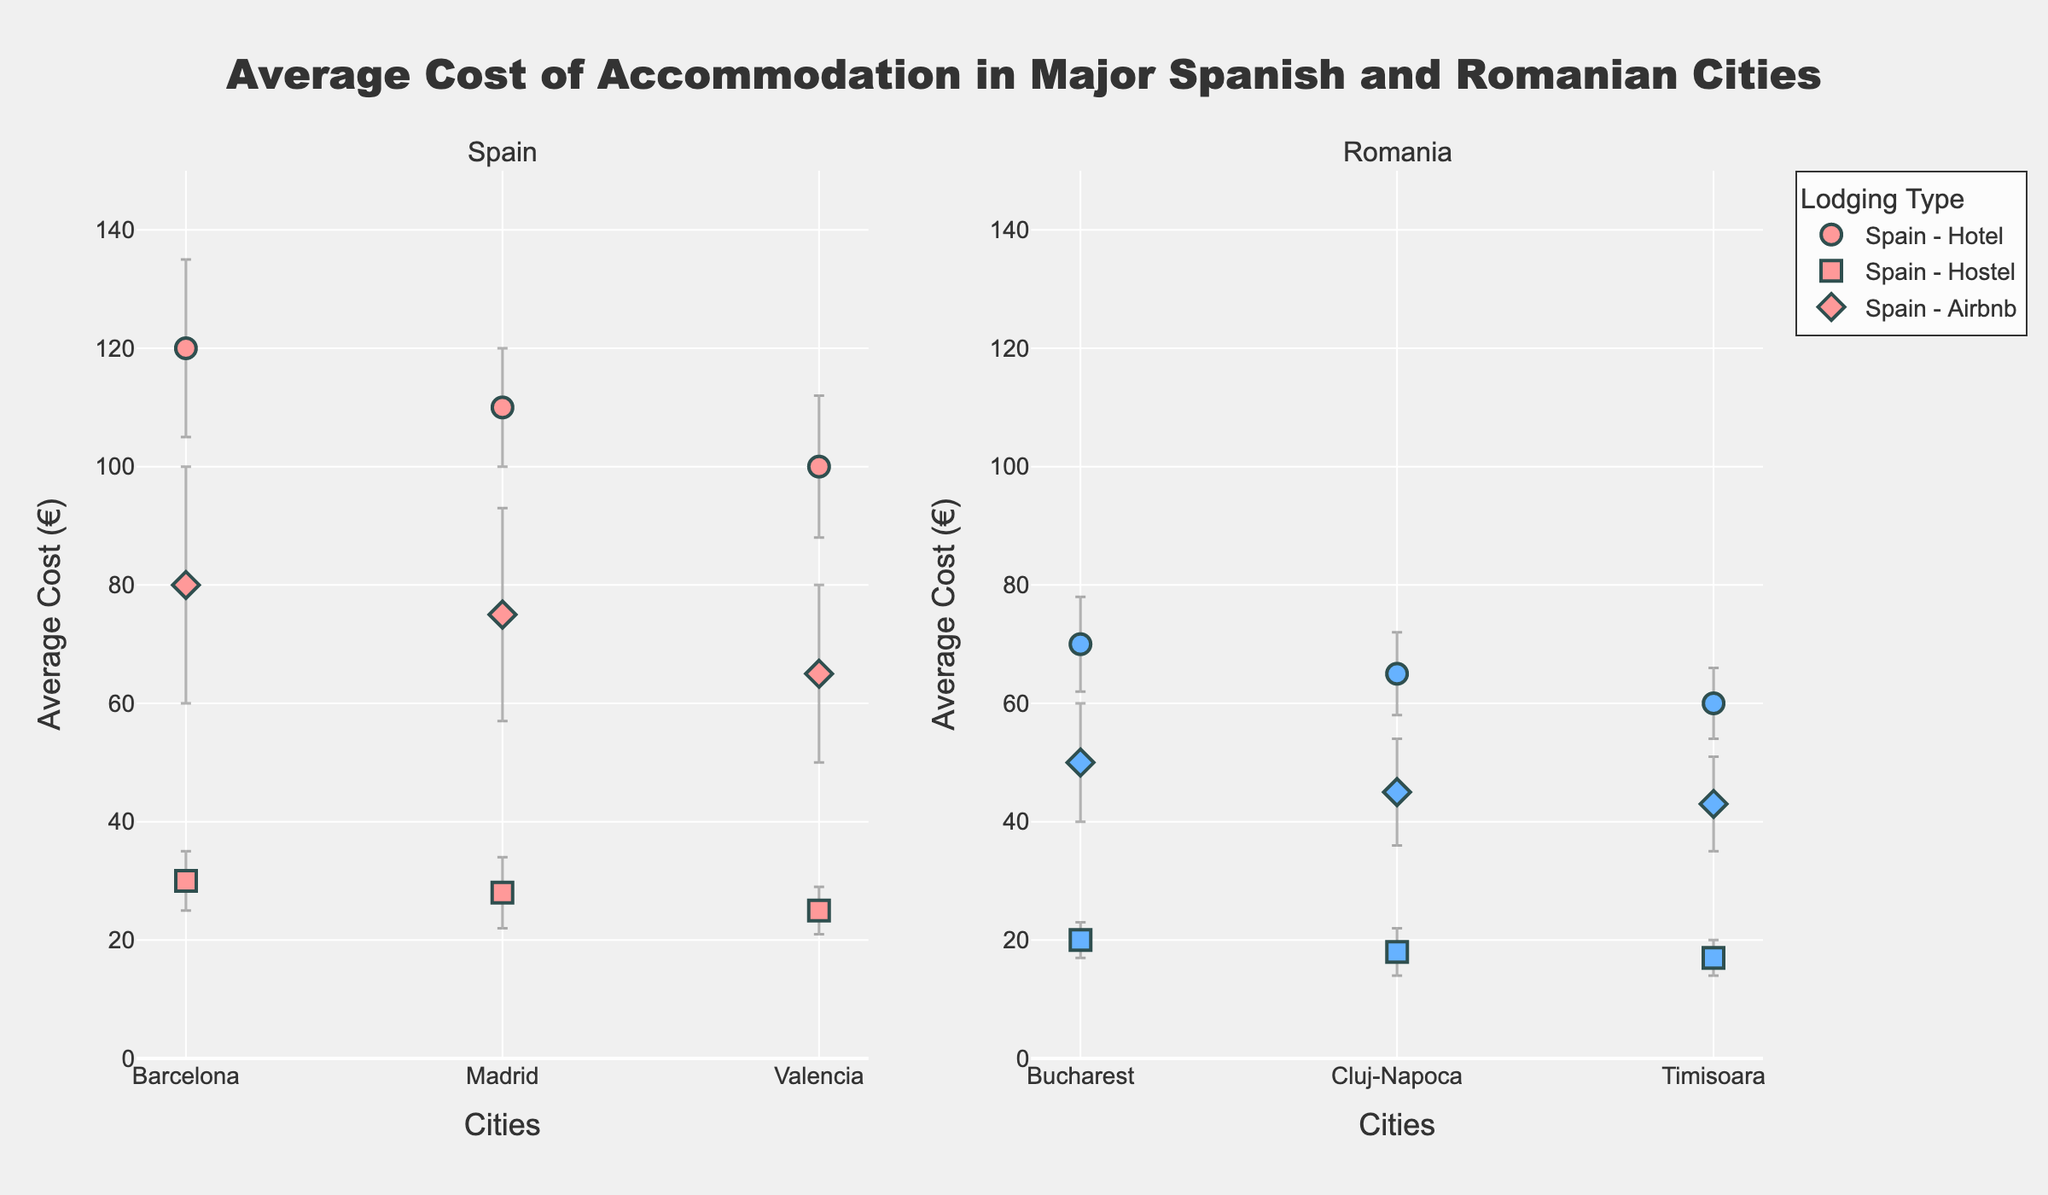What is the title of the figure? The title is typically displayed at the top of the figure. In this case, it reads "Average Cost of Accommodation in Major Spanish and Romanian Cities," which helps understand the overall topic of the plot.
Answer: Average Cost of Accommodation in Major Spanish and Romanian Cities Which cities have data points on the plot? By examining the x-axis labels, we observe that the cities represented on the figure are Barcelona, Madrid, and Valencia in Spain, and Bucharest, Cluj-Napoca, and Timisoara in Romania.
Answer: Barcelona, Madrid, Valencia, Bucharest, Cluj-Napoca, Timisoara What is the average cost of a hotel in Bucharest? Locate the data points for Bucharest in Romania. The data point symbolized by a circle represents hotels. The average cost shown for this circle is 70 euros.
Answer: 70 euros Which type of lodging tends to be the cheapest in all cities? Look at the three different lodging types (Hotels, Hostels, and Airbnbs) in all cities. Hostels, represented by squares, consistently have the lowest average cost compared to hotels (circles) and Airbnbs (diamonds).
Answer: Hostels Which city has the highest average cost for Airbnb? Identify the diamonds representing Airbnbs in each city. The highest point among them is in Barcelona, with an average cost of 80 euros.
Answer: Barcelona What is the range of standard deviations for hotels in Spanish cities? Examine the error bars for hotel data points (circles) in Spain. The standard deviations are 15 for Barcelona, 10 for Madrid, and 12 for Valencia, resulting in a range from 10 to 15.
Answer: 10 to 15 Compare the average costs of hotels between Barcelona and Madrid. Which city is more expensive, and by how much? Barcelona's hotel average cost is 120 euros, while Madrid's is 110 euros. So, Barcelona is more expensive by 10 euros.
Answer: Barcelona, 10 euros What is the overall trend in accommodation costs between Spain and Romania? Compare the average accommodation costs in the cities of Spain and Romania. Generally, Spanish cities (Barcelona, Madrid, Valencia) have higher average costs compared to Romanian cities (Bucharest, Cluj-Napoca, Timisoara) across all types of lodging.
Answer: Spain has higher costs Which city has the smallest standard deviation for hostels? Identify the squares representing hostels and look at the length of error bars (standard deviations). Timisoara has the smallest standard deviation of 3 euros for hostels.
Answer: Timisoara Is there a lodging type that shows more variability in costs across the cities? Assess the size of the error bars for each lodging type. Airbnbs (diamonds) generally show longer error bars, indicating greater variability in costs compared to hotels (circles) and hostels (squares).
Answer: Airbnbs 